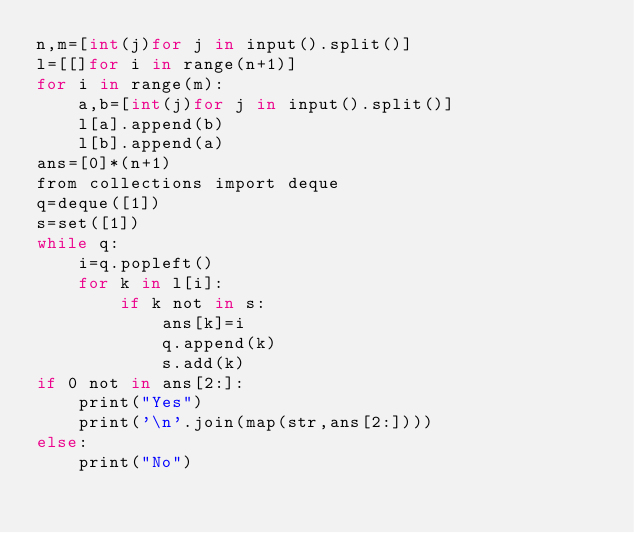<code> <loc_0><loc_0><loc_500><loc_500><_Cython_>n,m=[int(j)for j in input().split()]
l=[[]for i in range(n+1)]
for i in range(m):
    a,b=[int(j)for j in input().split()]
    l[a].append(b)
    l[b].append(a)
ans=[0]*(n+1)
from collections import deque
q=deque([1])
s=set([1])
while q:
    i=q.popleft()
    for k in l[i]:
        if k not in s:
            ans[k]=i
            q.append(k)
            s.add(k)
if 0 not in ans[2:]:
    print("Yes")
    print('\n'.join(map(str,ans[2:])))
else:
    print("No")</code> 